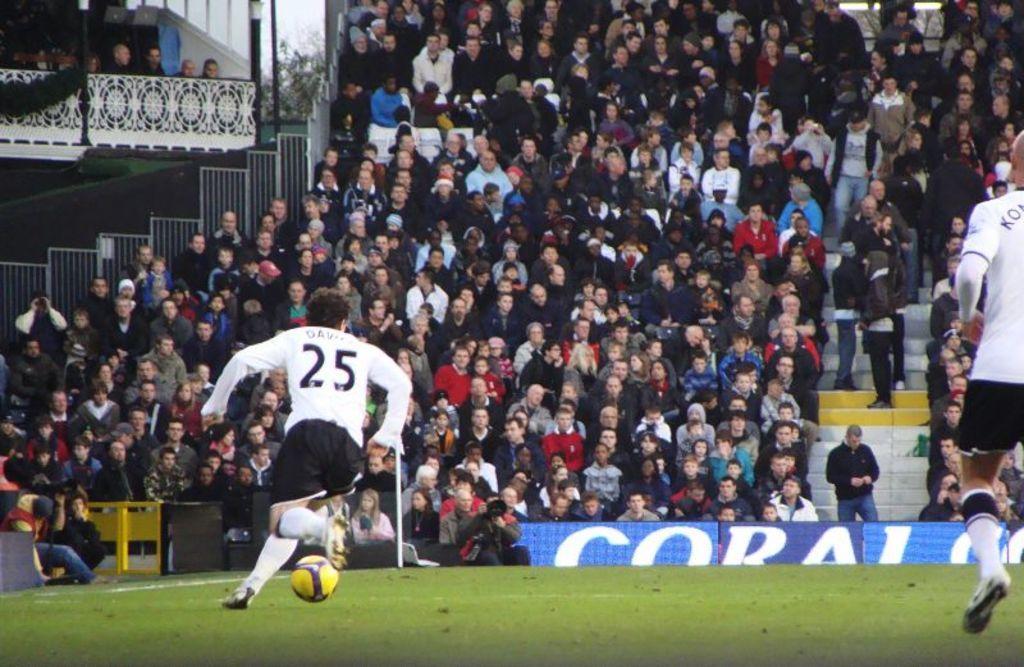In one or two sentences, can you explain what this image depicts? In this image I can see grass ground and on it I can see two men are standing. I can see both of them are wearing sports wear and on their dresses I can see something is written. Here I can see a yellow football and in the background I can see many more people where few are standing and few are sitting. I can also see a board over here and on it I can see something is written. 